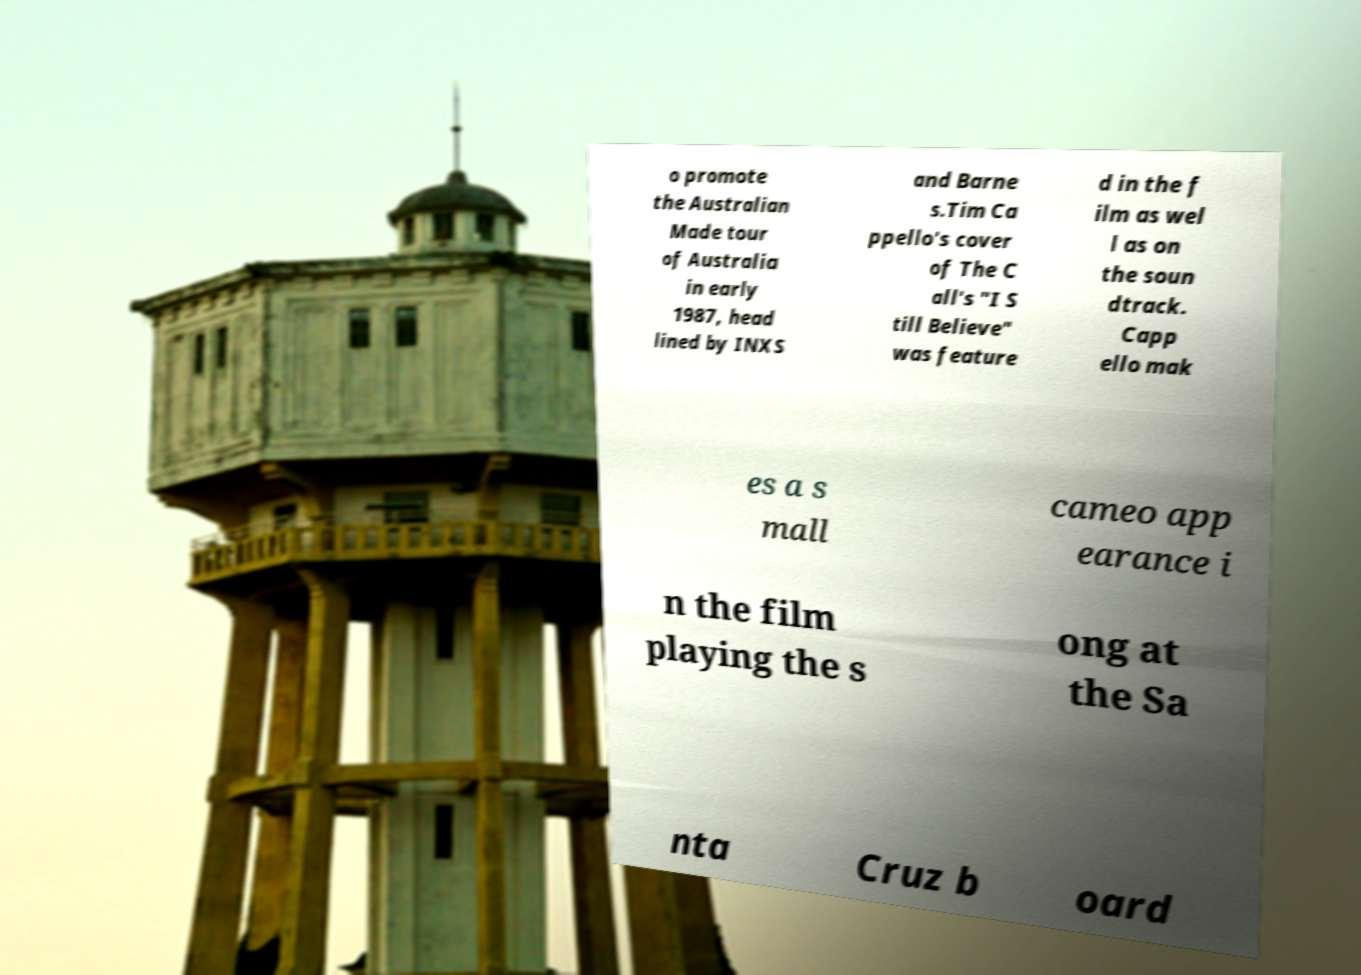Please read and relay the text visible in this image. What does it say? o promote the Australian Made tour of Australia in early 1987, head lined by INXS and Barne s.Tim Ca ppello's cover of The C all's "I S till Believe" was feature d in the f ilm as wel l as on the soun dtrack. Capp ello mak es a s mall cameo app earance i n the film playing the s ong at the Sa nta Cruz b oard 